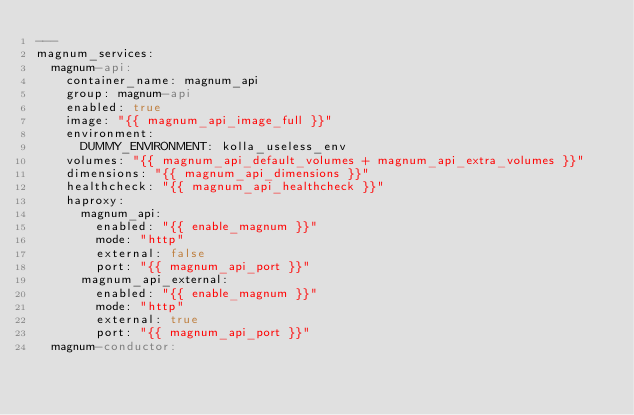<code> <loc_0><loc_0><loc_500><loc_500><_YAML_>---
magnum_services:
  magnum-api:
    container_name: magnum_api
    group: magnum-api
    enabled: true
    image: "{{ magnum_api_image_full }}"
    environment:
      DUMMY_ENVIRONMENT: kolla_useless_env
    volumes: "{{ magnum_api_default_volumes + magnum_api_extra_volumes }}"
    dimensions: "{{ magnum_api_dimensions }}"
    healthcheck: "{{ magnum_api_healthcheck }}"
    haproxy:
      magnum_api:
        enabled: "{{ enable_magnum }}"
        mode: "http"
        external: false
        port: "{{ magnum_api_port }}"
      magnum_api_external:
        enabled: "{{ enable_magnum }}"
        mode: "http"
        external: true
        port: "{{ magnum_api_port }}"
  magnum-conductor:</code> 